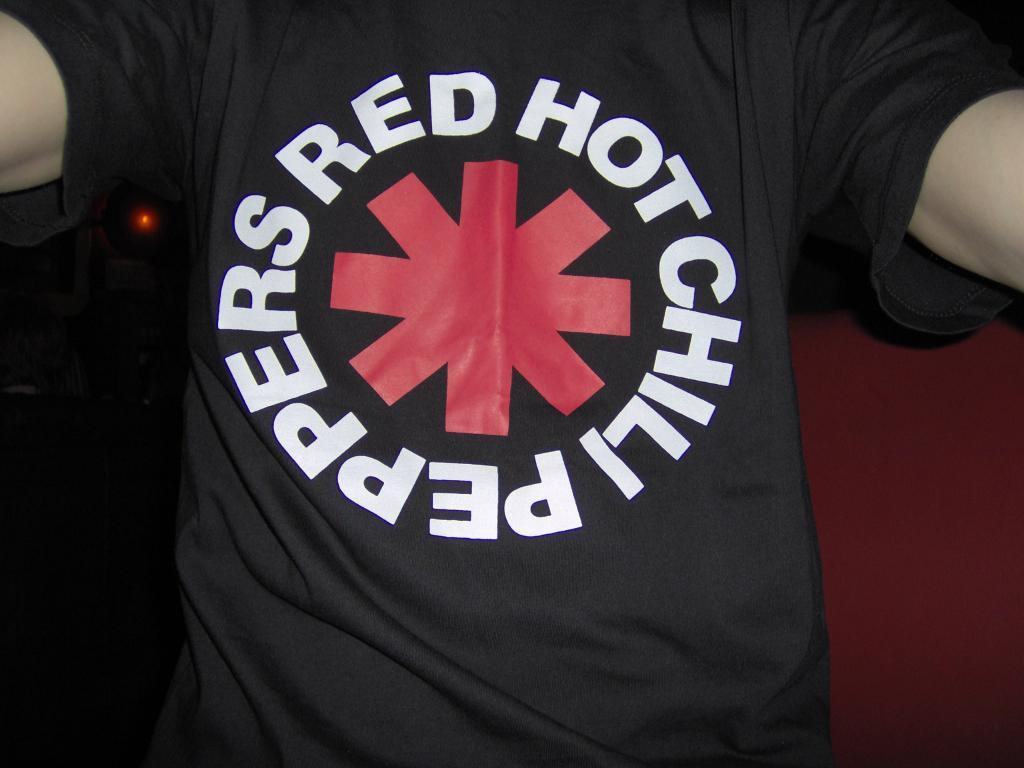<image>
Render a clear and concise summary of the photo. Someone wearing a Red Hot Chili Peppers shirt is taking a picture of their own stomach. 